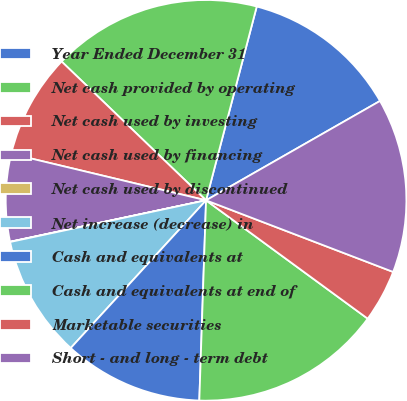Convert chart. <chart><loc_0><loc_0><loc_500><loc_500><pie_chart><fcel>Year Ended December 31<fcel>Net cash provided by operating<fcel>Net cash used by investing<fcel>Net cash used by financing<fcel>Net cash used by discontinued<fcel>Net increase (decrease) in<fcel>Cash and equivalents at<fcel>Cash and equivalents at end of<fcel>Marketable securities<fcel>Short - and long - term debt<nl><fcel>12.67%<fcel>16.89%<fcel>8.45%<fcel>7.05%<fcel>0.02%<fcel>9.86%<fcel>11.27%<fcel>15.48%<fcel>4.24%<fcel>14.08%<nl></chart> 